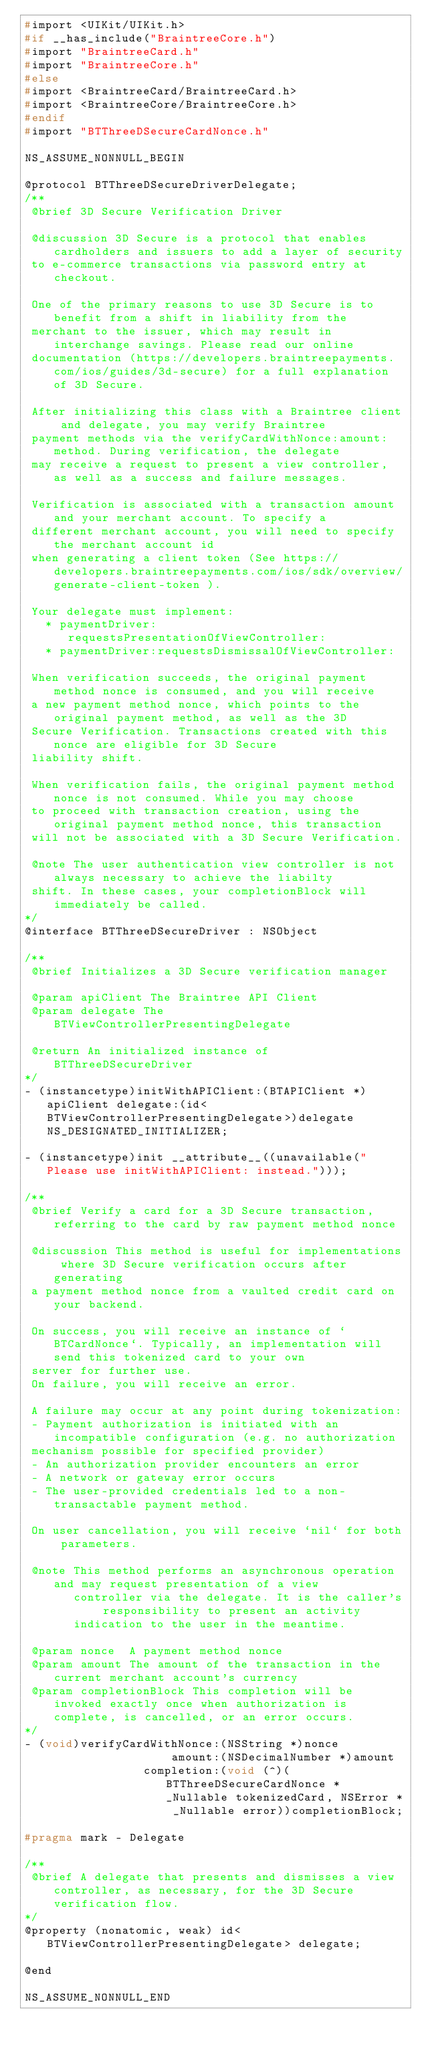<code> <loc_0><loc_0><loc_500><loc_500><_C_>#import <UIKit/UIKit.h>
#if __has_include("BraintreeCore.h")
#import "BraintreeCard.h"
#import "BraintreeCore.h"
#else
#import <BraintreeCard/BraintreeCard.h>
#import <BraintreeCore/BraintreeCore.h>
#endif
#import "BTThreeDSecureCardNonce.h"

NS_ASSUME_NONNULL_BEGIN

@protocol BTThreeDSecureDriverDelegate;
/**
 @brief 3D Secure Verification Driver

 @discussion 3D Secure is a protocol that enables cardholders and issuers to add a layer of security
 to e-commerce transactions via password entry at checkout.

 One of the primary reasons to use 3D Secure is to benefit from a shift in liability from the
 merchant to the issuer, which may result in interchange savings. Please read our online
 documentation (https://developers.braintreepayments.com/ios/guides/3d-secure) for a full explanation of 3D Secure.

 After initializing this class with a Braintree client and delegate, you may verify Braintree
 payment methods via the verifyCardWithNonce:amount: method. During verification, the delegate
 may receive a request to present a view controller, as well as a success and failure messages.

 Verification is associated with a transaction amount and your merchant account. To specify a
 different merchant account, you will need to specify the merchant account id
 when generating a client token (See https://developers.braintreepayments.com/ios/sdk/overview/generate-client-token ).

 Your delegate must implement:
   * paymentDriver:requestsPresentationOfViewController:
   * paymentDriver:requestsDismissalOfViewController:

 When verification succeeds, the original payment method nonce is consumed, and you will receive
 a new payment method nonce, which points to the original payment method, as well as the 3D
 Secure Verification. Transactions created with this nonce are eligible for 3D Secure
 liability shift.

 When verification fails, the original payment method nonce is not consumed. While you may choose
 to proceed with transaction creation, using the original payment method nonce, this transaction
 will not be associated with a 3D Secure Verification.

 @note The user authentication view controller is not always necessary to achieve the liabilty
 shift. In these cases, your completionBlock will immediately be called.
*/
@interface BTThreeDSecureDriver : NSObject

/**
 @brief Initializes a 3D Secure verification manager

 @param apiClient The Braintree API Client
 @param delegate The BTViewControllerPresentingDelegate

 @return An initialized instance of BTThreeDSecureDriver
*/
- (instancetype)initWithAPIClient:(BTAPIClient *)apiClient delegate:(id<BTViewControllerPresentingDelegate>)delegate NS_DESIGNATED_INITIALIZER;

- (instancetype)init __attribute__((unavailable("Please use initWithAPIClient: instead.")));

/**
 @brief Verify a card for a 3D Secure transaction, referring to the card by raw payment method nonce

 @discussion This method is useful for implementations where 3D Secure verification occurs after generating
 a payment method nonce from a vaulted credit card on your backend.
 
 On success, you will receive an instance of `BTCardNonce`. Typically, an implementation will send this tokenized card to your own
 server for further use.
 On failure, you will receive an error.
 
 A failure may occur at any point during tokenization:
 - Payment authorization is initiated with an incompatible configuration (e.g. no authorization
 mechanism possible for specified provider)
 - An authorization provider encounters an error
 - A network or gateway error occurs
 - The user-provided credentials led to a non-transactable payment method.
 
 On user cancellation, you will receive `nil` for both parameters.

 @note This method performs an asynchronous operation and may request presentation of a view
       controller via the delegate. It is the caller's responsibility to present an activity
       indication to the user in the meantime.

 @param nonce  A payment method nonce
 @param amount The amount of the transaction in the current merchant account's currency
 @param completionBlock This completion will be invoked exactly once when authorization is complete, is cancelled, or an error occurs.
*/
- (void)verifyCardWithNonce:(NSString *)nonce
                     amount:(NSDecimalNumber *)amount
                 completion:(void (^)(BTThreeDSecureCardNonce * _Nullable tokenizedCard, NSError * _Nullable error))completionBlock;

#pragma mark - Delegate

/**
 @brief A delegate that presents and dismisses a view controller, as necessary, for the 3D Secure verification flow.
*/
@property (nonatomic, weak) id<BTViewControllerPresentingDelegate> delegate;

@end

NS_ASSUME_NONNULL_END
</code> 